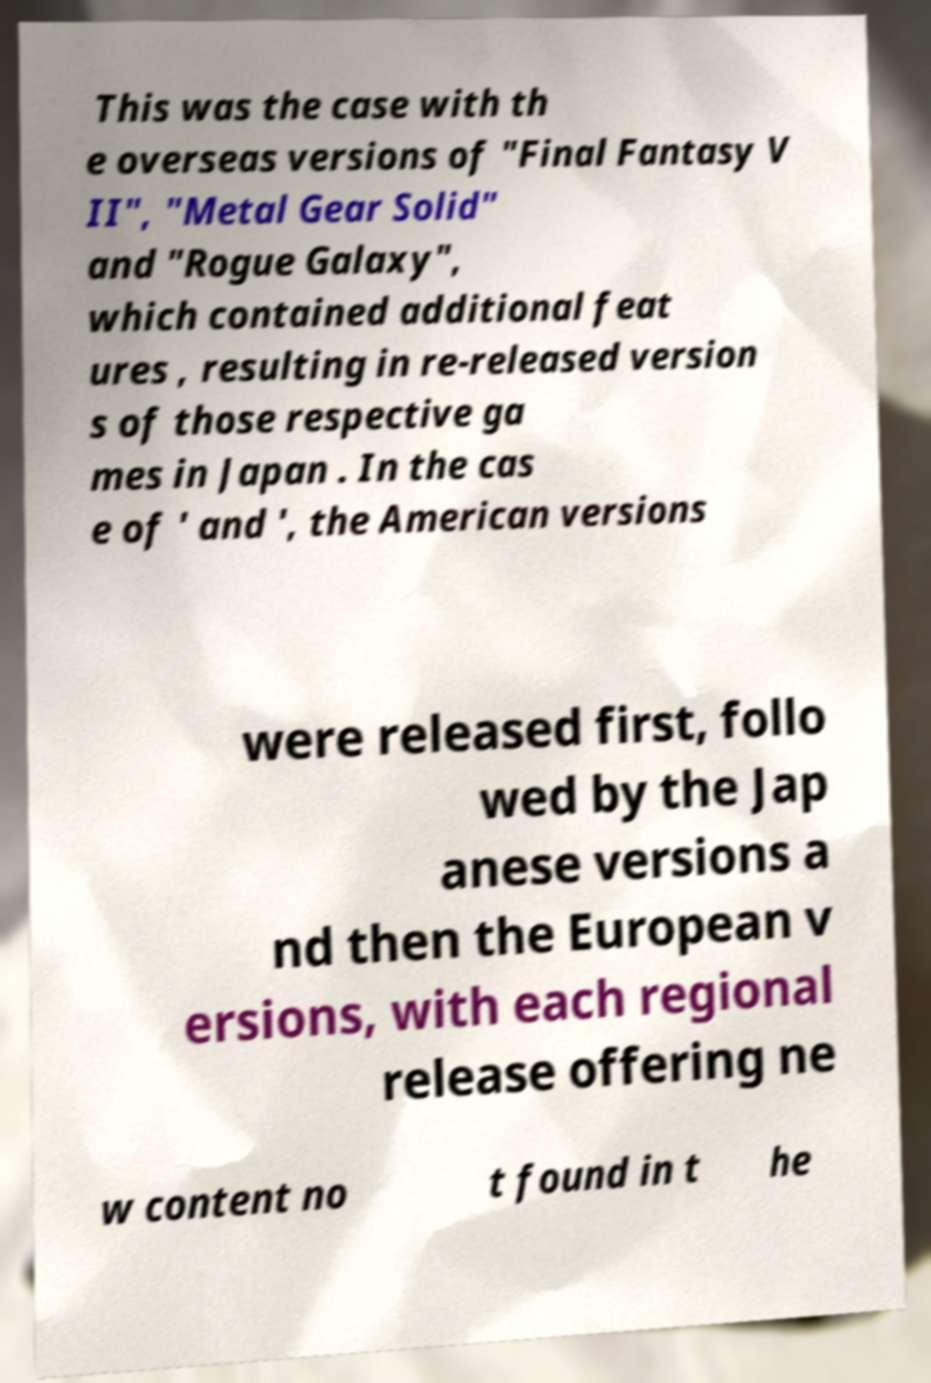Please identify and transcribe the text found in this image. This was the case with th e overseas versions of "Final Fantasy V II", "Metal Gear Solid" and "Rogue Galaxy", which contained additional feat ures , resulting in re-released version s of those respective ga mes in Japan . In the cas e of ' and ', the American versions were released first, follo wed by the Jap anese versions a nd then the European v ersions, with each regional release offering ne w content no t found in t he 